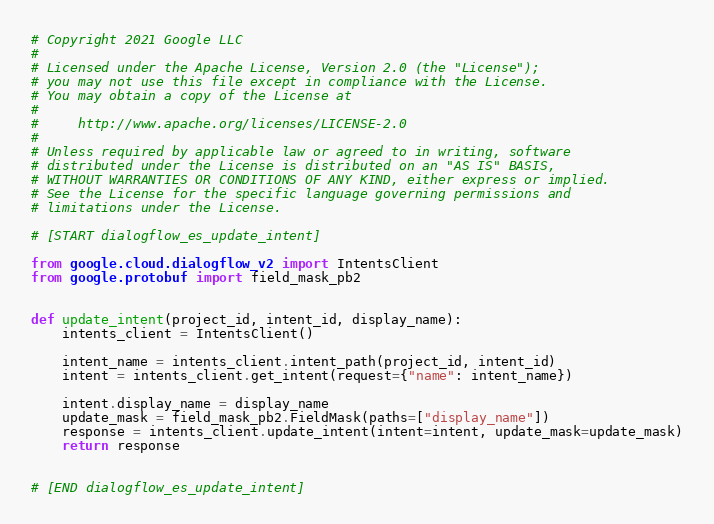Convert code to text. <code><loc_0><loc_0><loc_500><loc_500><_Python_># Copyright 2021 Google LLC
#
# Licensed under the Apache License, Version 2.0 (the "License");
# you may not use this file except in compliance with the License.
# You may obtain a copy of the License at
#
#     http://www.apache.org/licenses/LICENSE-2.0
#
# Unless required by applicable law or agreed to in writing, software
# distributed under the License is distributed on an "AS IS" BASIS,
# WITHOUT WARRANTIES OR CONDITIONS OF ANY KIND, either express or implied.
# See the License for the specific language governing permissions and
# limitations under the License.

# [START dialogflow_es_update_intent]

from google.cloud.dialogflow_v2 import IntentsClient
from google.protobuf import field_mask_pb2


def update_intent(project_id, intent_id, display_name):
    intents_client = IntentsClient()

    intent_name = intents_client.intent_path(project_id, intent_id)
    intent = intents_client.get_intent(request={"name": intent_name})

    intent.display_name = display_name
    update_mask = field_mask_pb2.FieldMask(paths=["display_name"])
    response = intents_client.update_intent(intent=intent, update_mask=update_mask)
    return response


# [END dialogflow_es_update_intent]
</code> 